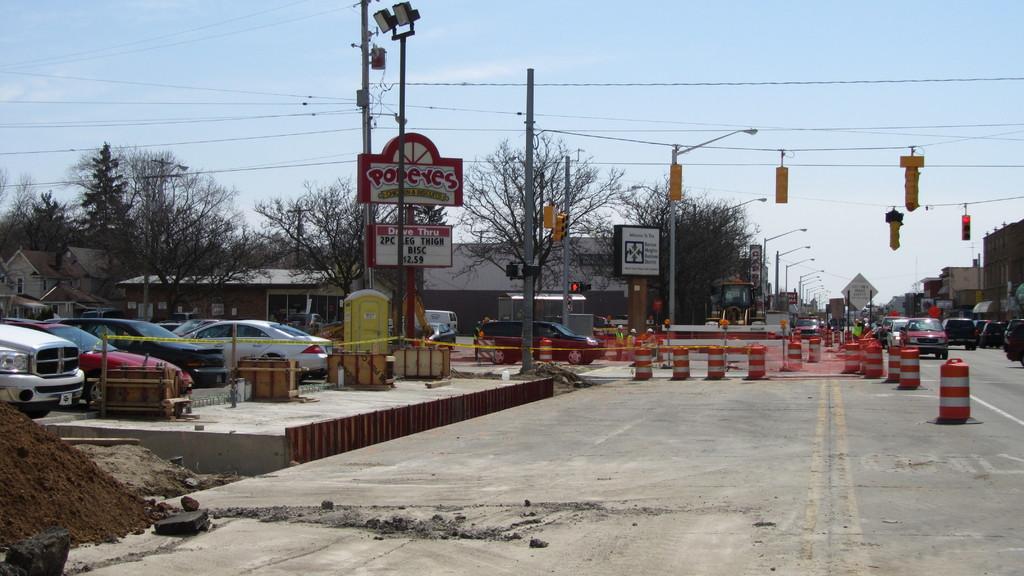What store is in the picture?
Keep it short and to the point. Popeyes. What is the fast food place on the left?
Your answer should be compact. Popeyes. 